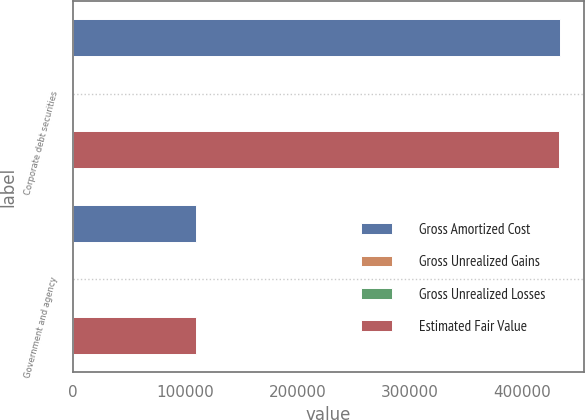Convert chart to OTSL. <chart><loc_0><loc_0><loc_500><loc_500><stacked_bar_chart><ecel><fcel>Corporate debt securities<fcel>Government and agency<nl><fcel>Gross Amortized Cost<fcel>433192<fcel>109652<nl><fcel>Gross Unrealized Gains<fcel>36<fcel>1<nl><fcel>Gross Unrealized Losses<fcel>640<fcel>138<nl><fcel>Estimated Fair Value<fcel>432588<fcel>109515<nl></chart> 